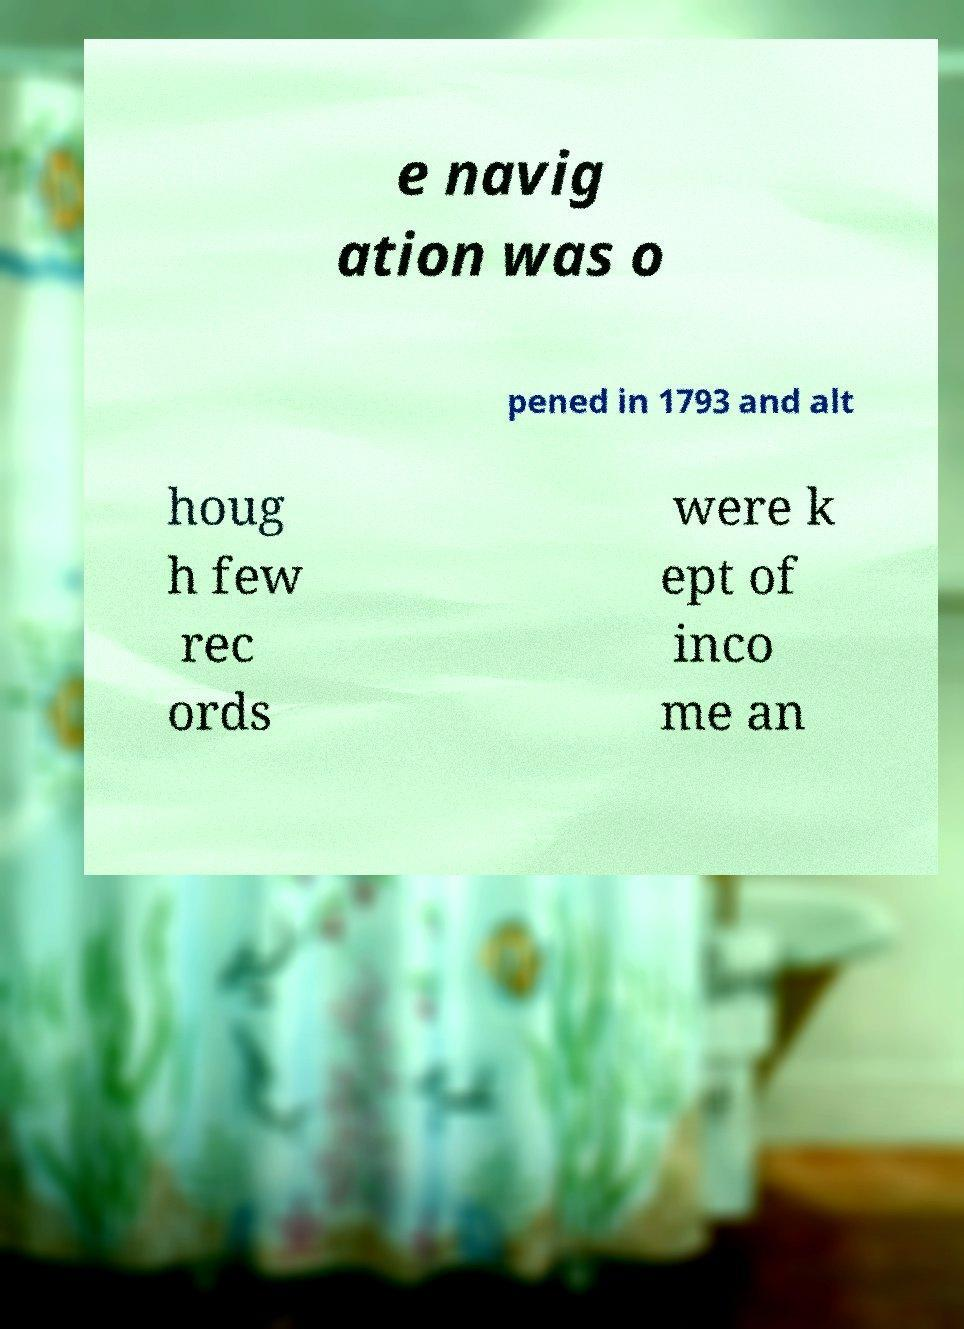Could you extract and type out the text from this image? e navig ation was o pened in 1793 and alt houg h few rec ords were k ept of inco me an 